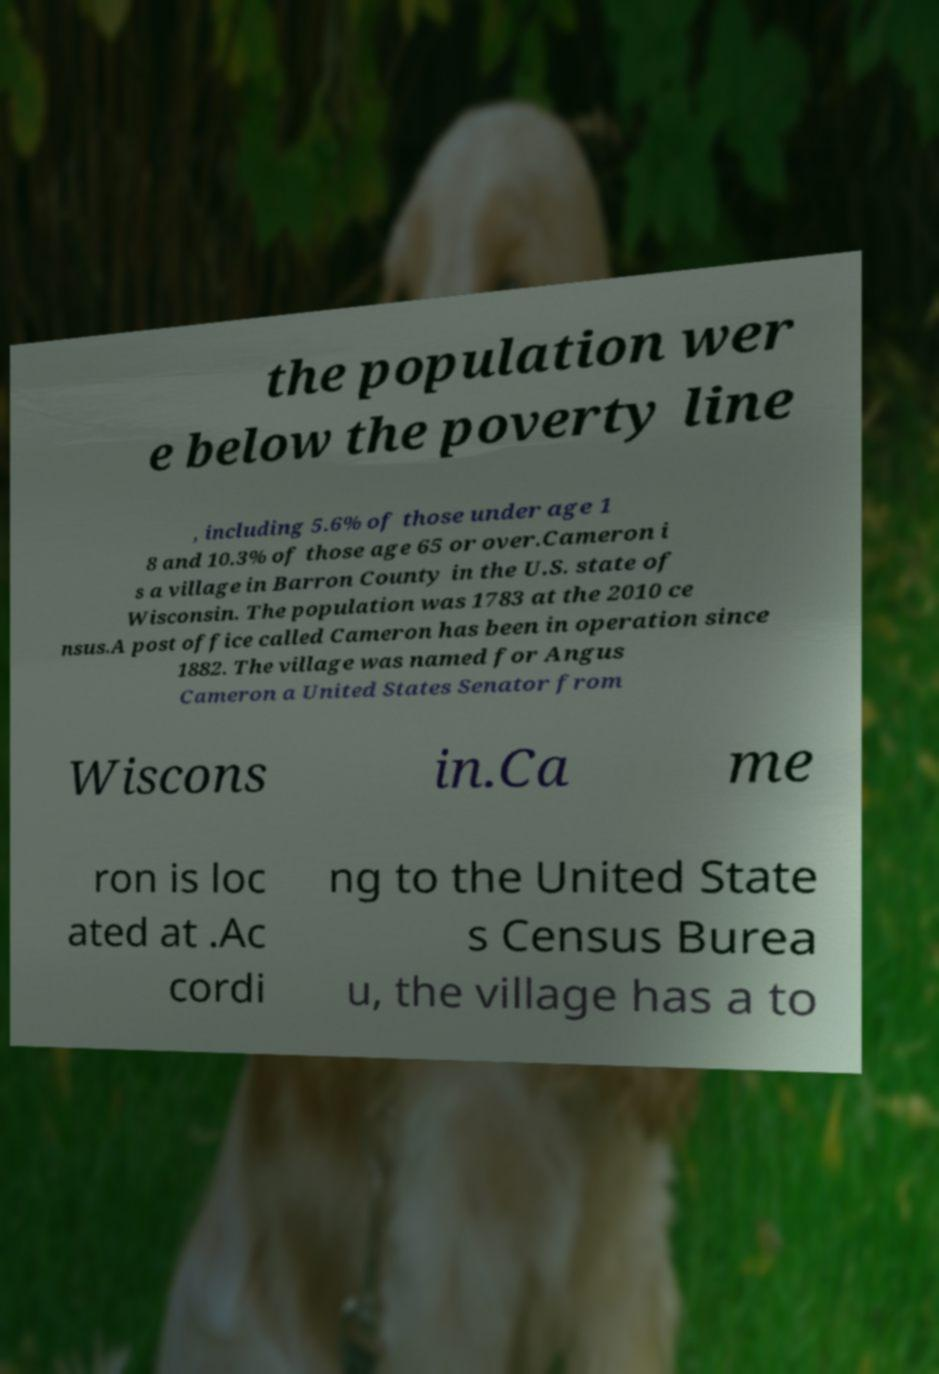Please identify and transcribe the text found in this image. the population wer e below the poverty line , including 5.6% of those under age 1 8 and 10.3% of those age 65 or over.Cameron i s a village in Barron County in the U.S. state of Wisconsin. The population was 1783 at the 2010 ce nsus.A post office called Cameron has been in operation since 1882. The village was named for Angus Cameron a United States Senator from Wiscons in.Ca me ron is loc ated at .Ac cordi ng to the United State s Census Burea u, the village has a to 